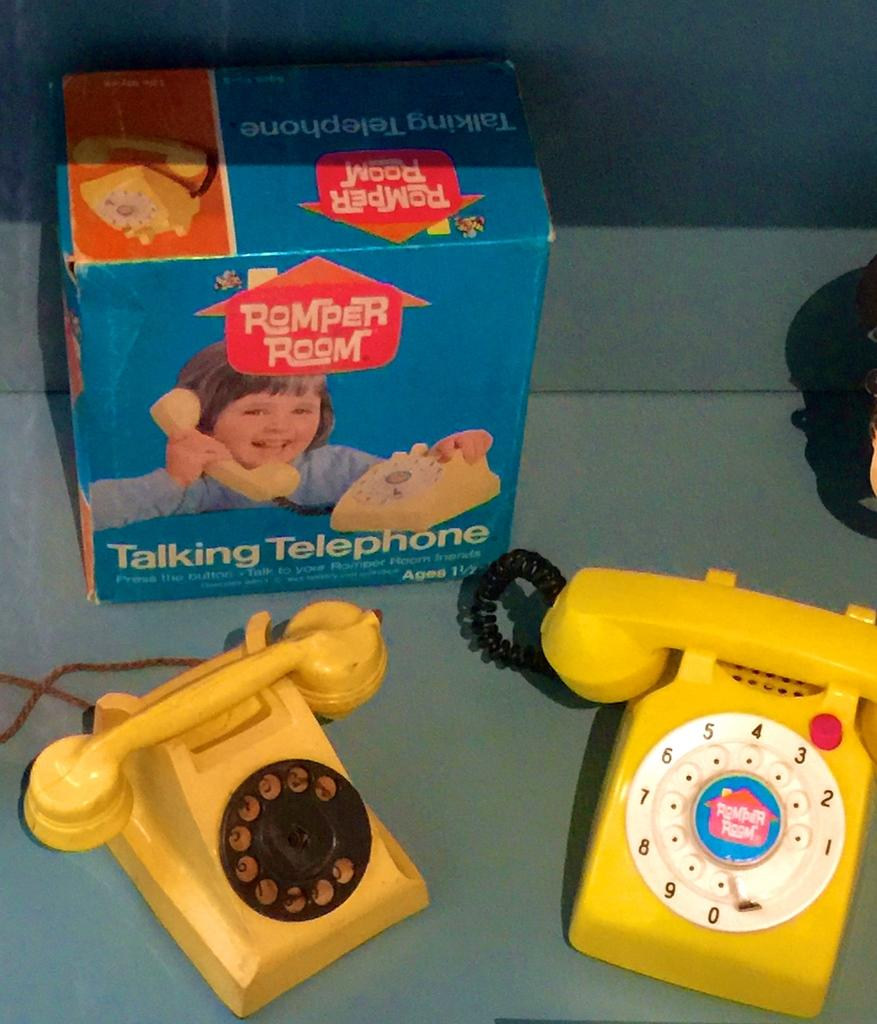<image>
Create a compact narrative representing the image presented. A couple of play telephones including a Romper Room talking telephone. 